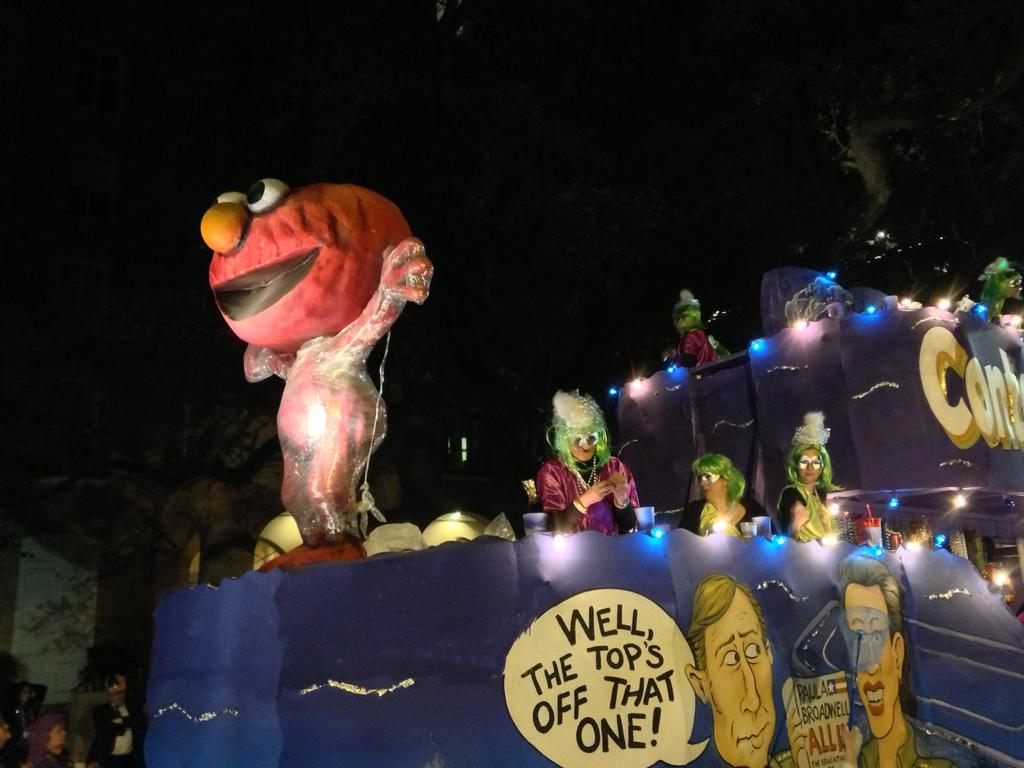What type of visual content is present in the image? There are cartoons in the image. What else can be seen on the boards in the image? There are boards with writing in the image. What can be used to illuminate the area in the image? There are lights visible in the image. What type of dress is the expert wearing in the image? There is no expert or dress present in the image. What type of spade can be seen in the image? There is no spade present in the image. 